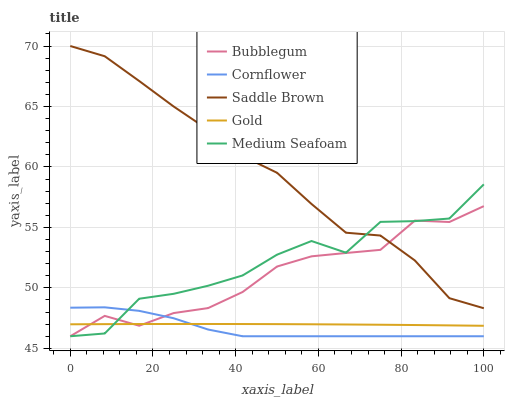Does Cornflower have the minimum area under the curve?
Answer yes or no. Yes. Does Saddle Brown have the maximum area under the curve?
Answer yes or no. Yes. Does Gold have the minimum area under the curve?
Answer yes or no. No. Does Gold have the maximum area under the curve?
Answer yes or no. No. Is Gold the smoothest?
Answer yes or no. Yes. Is Medium Seafoam the roughest?
Answer yes or no. Yes. Is Saddle Brown the smoothest?
Answer yes or no. No. Is Saddle Brown the roughest?
Answer yes or no. No. Does Gold have the lowest value?
Answer yes or no. No. Does Saddle Brown have the highest value?
Answer yes or no. Yes. Does Gold have the highest value?
Answer yes or no. No. Is Cornflower less than Saddle Brown?
Answer yes or no. Yes. Is Saddle Brown greater than Gold?
Answer yes or no. Yes. Does Cornflower intersect Bubblegum?
Answer yes or no. Yes. Is Cornflower less than Bubblegum?
Answer yes or no. No. Is Cornflower greater than Bubblegum?
Answer yes or no. No. Does Cornflower intersect Saddle Brown?
Answer yes or no. No. 